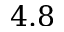<formula> <loc_0><loc_0><loc_500><loc_500>4 . 8</formula> 